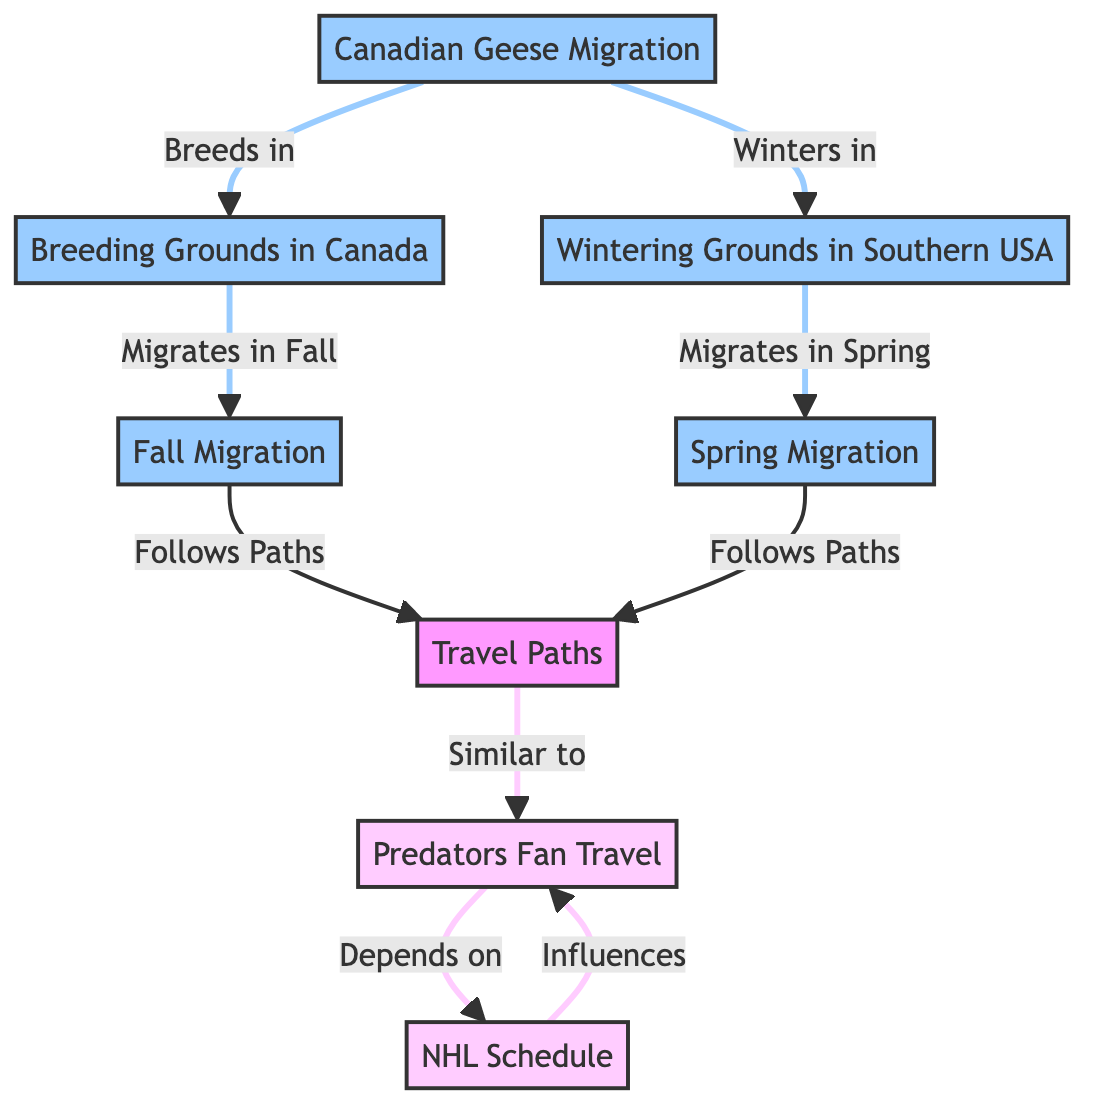What's the main breeding ground for Canadian geese? The diagram directly shows that the Canadian geese breed in "Breeding Grounds in Canada".
Answer: Breeding Grounds in Canada How many main migration paths are represented for Canadian geese? The diagram indicates two main migration paths: "Fall Migration" and "Spring Migration".
Answer: 2 What influences the travel patterns of Predators fans? The diagram indicates that fan travel patterns are influenced by the "NHL Schedule".
Answer: NHL Schedule Which season do Canadian geese migrate to their wintering grounds? The diagram clearly states that Canadian geese migrate to their wintering grounds in the "Fall".
Answer: Fall How do the travel paths of Canadian geese compare to Predators fans' travel? The diagram indicates that both "Fall Migration" and "Spring Migration" follow travel paths that are "Similar to" Predators fan travel.
Answer: Similar to What geographical location do Canadian geese winter in? The diagram states that Canadian geese winter in "Wintering Grounds in Southern USA".
Answer: Wintering Grounds in Southern USA What happens to Canadian geese in the Spring according to the diagram? The diagram shows that in the Spring, Canadian geese "Migrates in Spring" to their breeding grounds.
Answer: Migrates in Spring How do Canadian geese's fall migration patterns correlate to fan travel? The diagram shows that Canadian geese's "Fall Migration" follows paths similar to "Predators Fan Travel".
Answer: Similar to What does the "TP" node represent in the diagram? The "TP" node represents "Travel Paths" that both Canadian geese and Predators fans utilize based on their migration schedules.
Answer: Travel Paths 